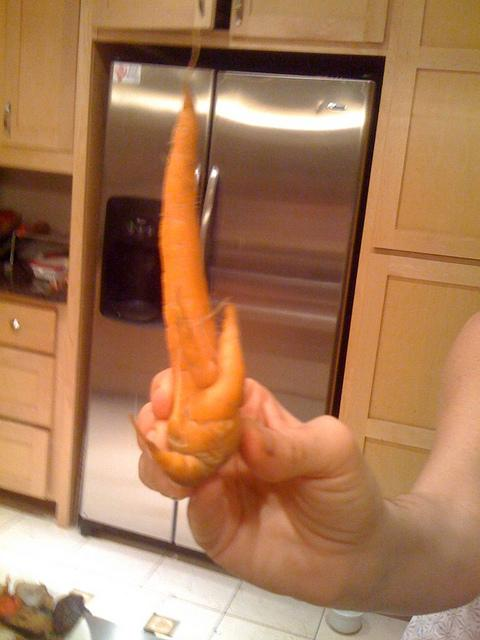What food category is this object in? vegetable 